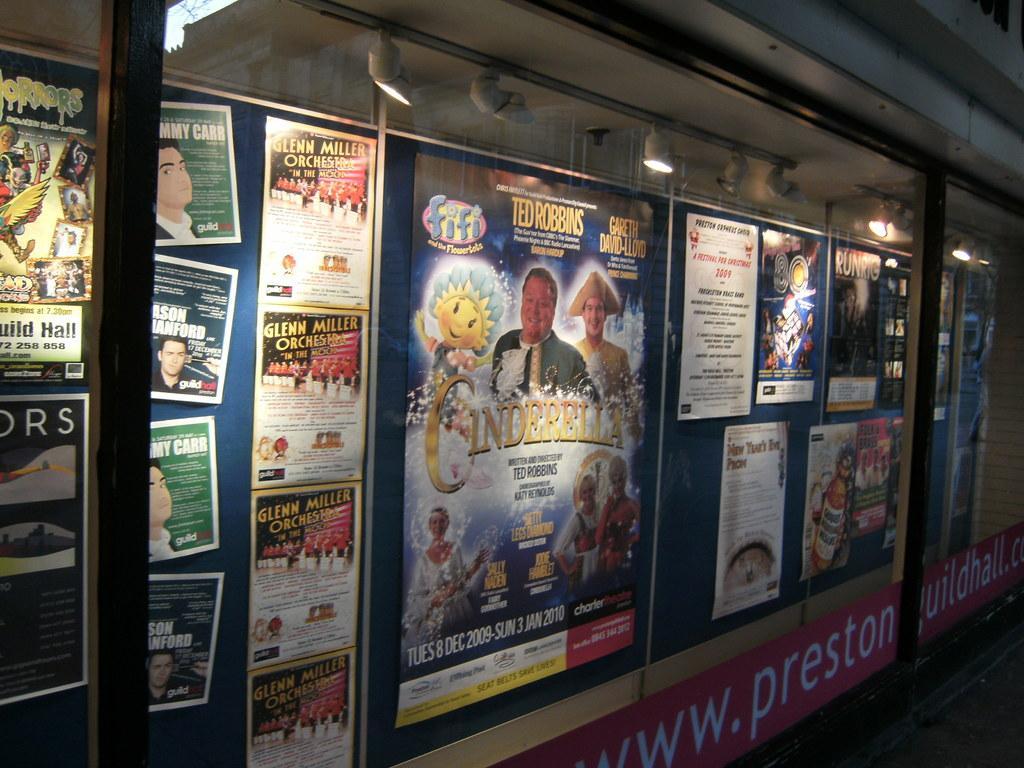Describe this image in one or two sentences. In this image there is wall to that wall there are posters, on the top there are lights. 